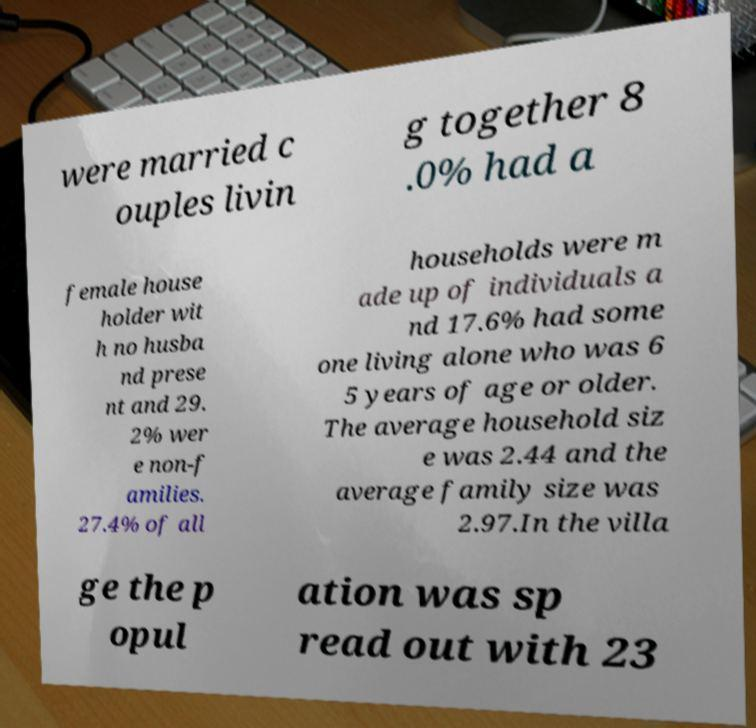Please identify and transcribe the text found in this image. were married c ouples livin g together 8 .0% had a female house holder wit h no husba nd prese nt and 29. 2% wer e non-f amilies. 27.4% of all households were m ade up of individuals a nd 17.6% had some one living alone who was 6 5 years of age or older. The average household siz e was 2.44 and the average family size was 2.97.In the villa ge the p opul ation was sp read out with 23 